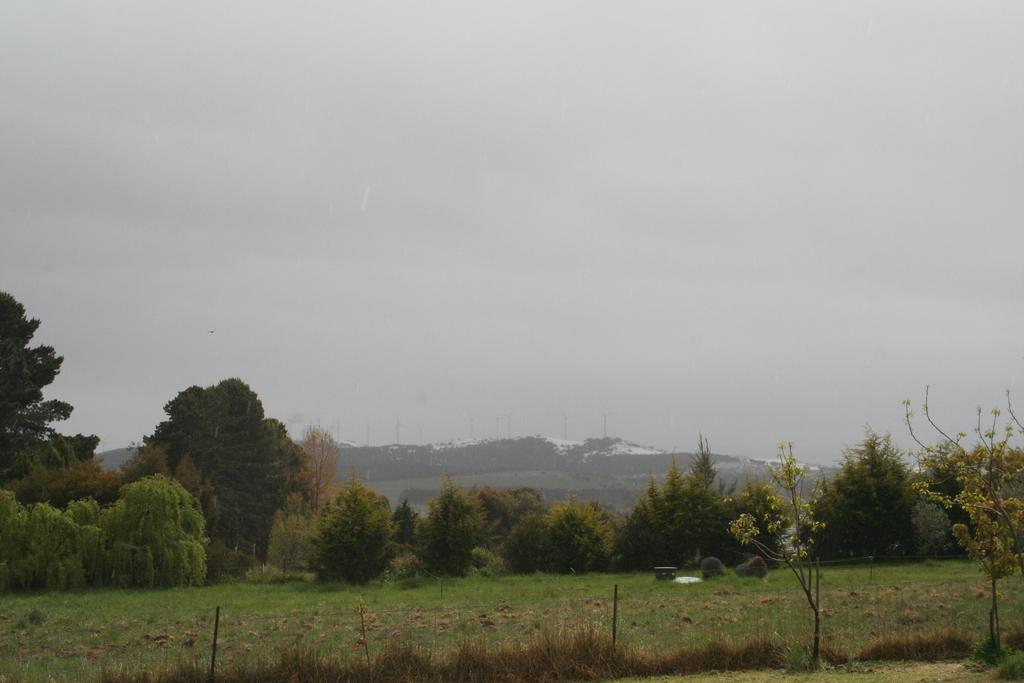What type of natural elements are present in the image? There are trees and plants in the image. What is the color of the trees and plants in the image? The trees and plants are in green color. What can be seen in the background of the image? There are buildings in the background of the image. What is visible in the sky in the image? The sky is visible in the image and is in white color. How many boats are visible in the image? There are no boats present in the image. What type of wealth is depicted in the image? The image does not depict any wealth or property; it primarily features trees, plants, buildings, and the sky. 